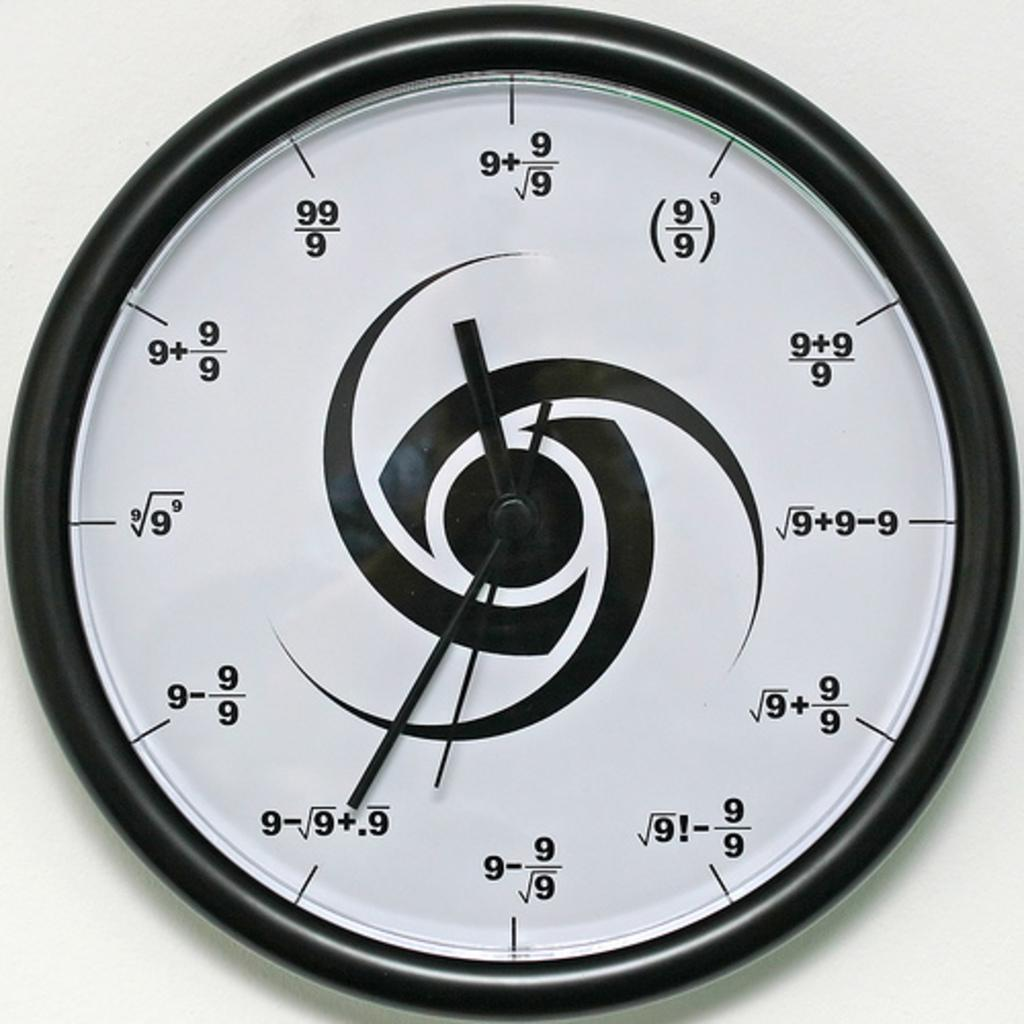<image>
Provide a brief description of the given image. A black and white wall clock has mathematical equations that result in the number of the hour, in each hour position. 